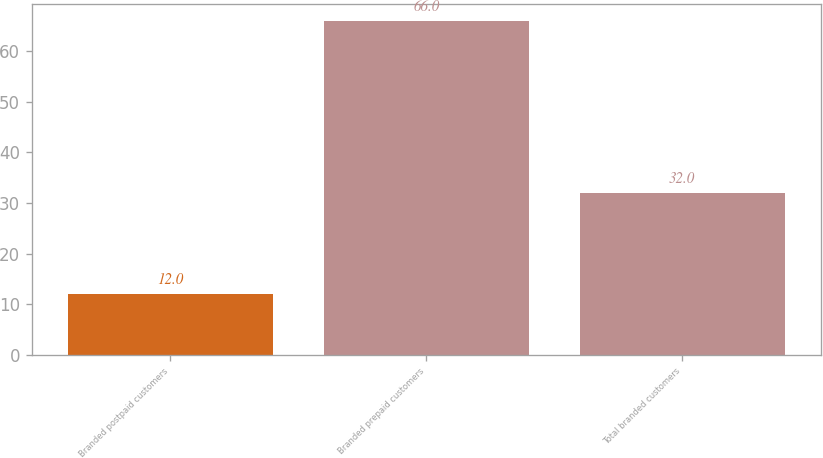Convert chart. <chart><loc_0><loc_0><loc_500><loc_500><bar_chart><fcel>Branded postpaid customers<fcel>Branded prepaid customers<fcel>Total branded customers<nl><fcel>12<fcel>66<fcel>32<nl></chart> 